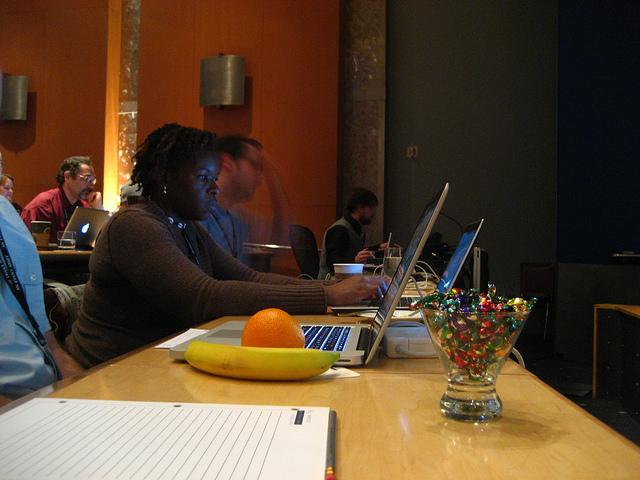What kind of building was this picture taken in?
Be succinct. School. Are there more candies or pieces of fruit on the table?
Be succinct. Candies. Is there an orange on this desk?
Concise answer only. Yes. What type of place is this?
Be succinct. Cafe. How many cakes are there?
Concise answer only. 0. Is this a dinner table?
Be succinct. No. What fruit is on the table?
Write a very short answer. Banana and orange. What is on the table?
Keep it brief. Banana and orange. 